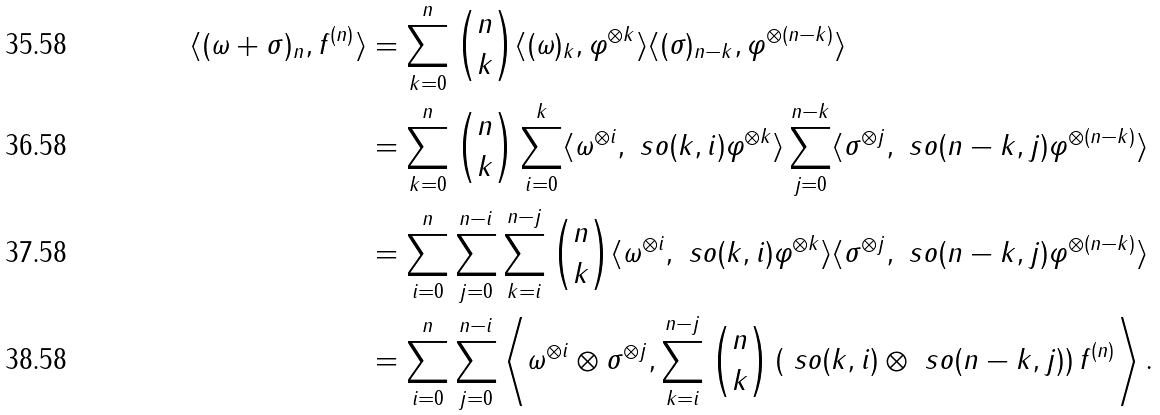<formula> <loc_0><loc_0><loc_500><loc_500>\langle ( \omega + \sigma ) _ { n } , f ^ { ( n ) } \rangle & = \sum _ { k = 0 } ^ { n } \binom { n } { k } \langle ( \omega ) _ { k } , \varphi ^ { \otimes k } \rangle \langle ( \sigma ) _ { n - k } , \varphi ^ { \otimes ( n - k ) } \rangle \\ & = \sum _ { k = 0 } ^ { n } \binom { n } { k } \sum _ { i = 0 } ^ { k } \langle \omega ^ { \otimes i } , \ s o ( k , i ) \varphi ^ { \otimes k } \rangle \sum _ { j = 0 } ^ { n - k } \langle \sigma ^ { \otimes j } , \ s o ( n - k , j ) \varphi ^ { \otimes ( n - k ) } \rangle \\ & = \sum _ { i = 0 } ^ { n } \sum _ { j = 0 } ^ { n - i } \sum _ { k = i } ^ { n - j } \binom { n } { k } \langle \omega ^ { \otimes i } , \ s o ( k , i ) \varphi ^ { \otimes k } \rangle \langle \sigma ^ { \otimes j } , \ s o ( n - k , j ) \varphi ^ { \otimes ( n - k ) } \rangle \\ & = \sum _ { i = 0 } ^ { n } \sum _ { j = 0 } ^ { n - i } \left \langle \omega ^ { \otimes i } \otimes \sigma ^ { \otimes j } , \sum _ { k = i } ^ { n - j } \binom { n } { k } \left ( \ s o ( k , i ) \otimes \ s o ( n - k , j ) \right ) f ^ { ( n ) } \right \rangle .</formula> 